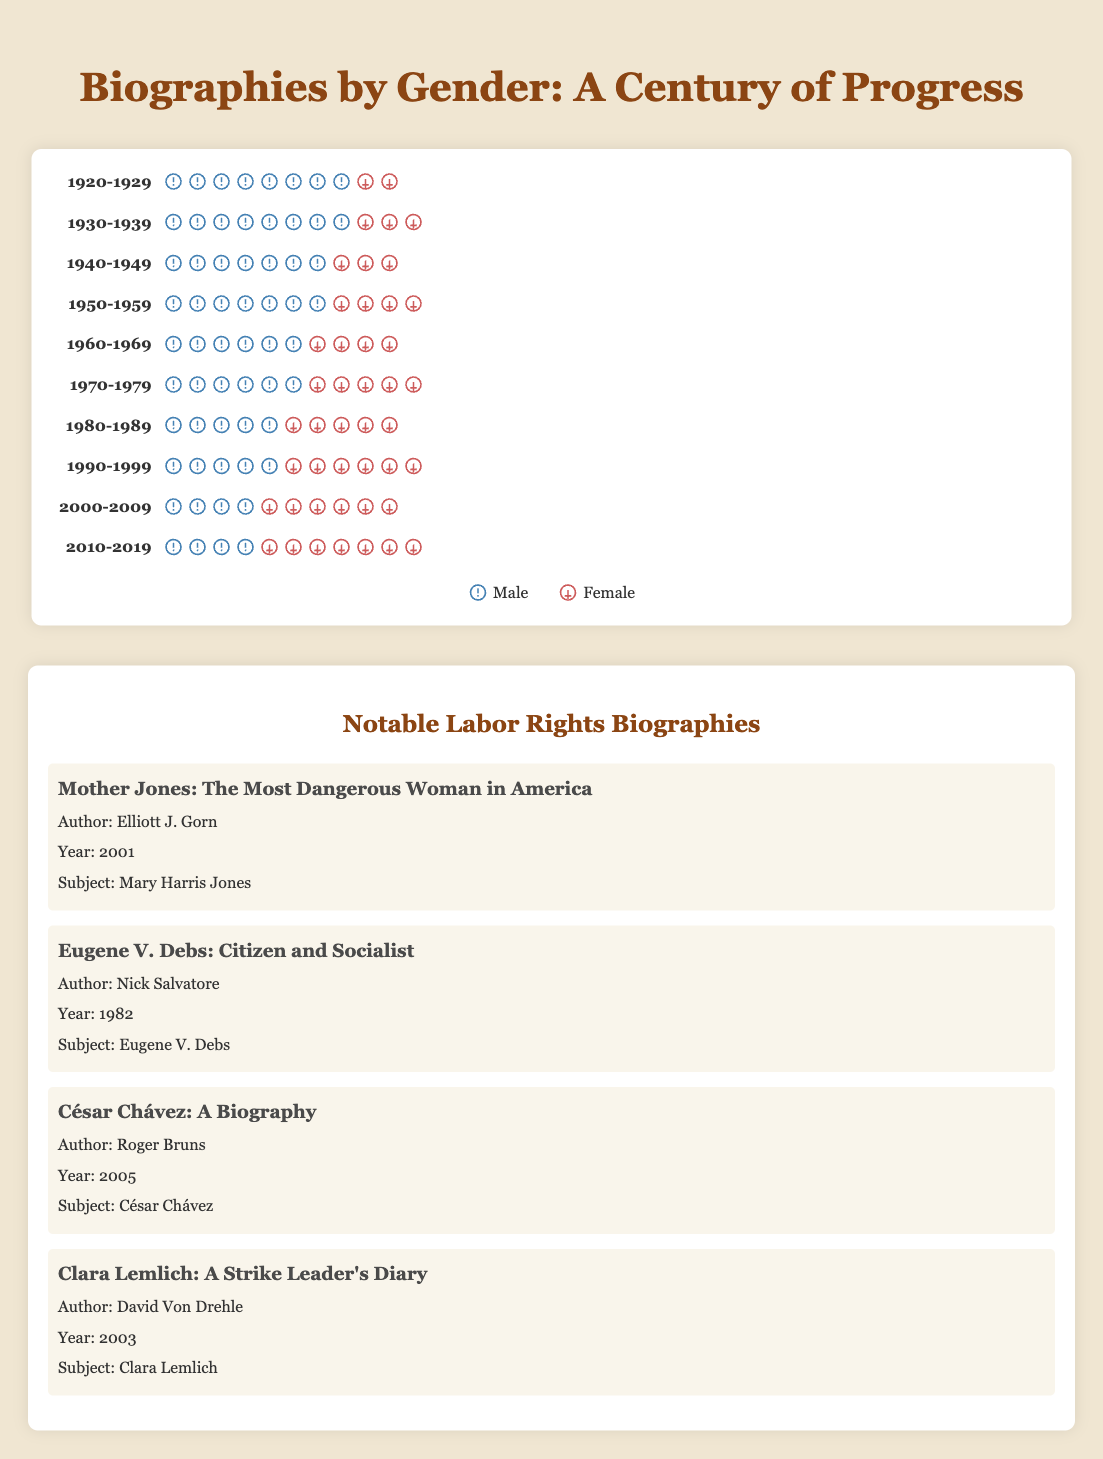What is the title of the figure? The title is located at the top of the figure and reads "Biographies by Gender: A Century of Progress".
Answer: Biographies by Gender: A Century of Progress Which decade had the highest percentage of female biographies? To find this, we look for the decade with the highest value in the female category. The 2010-2019 period shows the highest percentage with 65%.
Answer: 2010-2019 How many male and female biographies were there on average across the total periods? Add up all the male and female values separately and divide by the number of periods (10 decades): Male average = (80+75+70+65+60+55+50+45+40+35)/10 = 57.5, Female average = (20+25+30+35+40+45+50+55+60+65)/10 = 42.5
Answer: Male: 57.5, Female: 42.5 Did the number of female biographies ever surpass the number of male biographies within a decade? Compare the female and male values for each decade. Starting from the 1990-1999 period, female biographies (55) surpassed male biographies (45).
Answer: Yes What's the difference in the total number of biographies between the 1920-1929 and 2010-2019 periods? Total for 1920-1929 = 80 (male) + 20 (female) = 100; Total for 2010-2019 = 35 (male) + 65 (female) = 100; Difference = 100 - 100 = 0
Answer: 0 Which decade shows an equal percentage of male and female biographies? The 1980-1989 period shows 50% male and 50% female, indicating equal representation.
Answer: 1980-1989 By how many percentage points did the female biographies increase from the 1950-1959 period to the 2010-2019 period? The percentage of female biographies in 1950-1959 was 35%, and in 2010-2019 it was 65%. The increase is 65% - 35% = 30%.
Answer: 30 percentage points What notable biography was authored in 2001, and who was the subject? According to the list of notable labor rights biographies, "Mother Jones: The Most Dangerous Woman in America" was authored by Elliott J. Gorn in 2001. The subject is Mary Harris Jones.
Answer: Mother Jones: The Most Dangerous Woman in America; Mary Harris Jones In which decade did the percentage of male biographies first drop below 50%? By examining the percentages, we see that in the 1990-1999 period, male biographies dropped to 45%, which is below 50%.
Answer: 1990-1999 